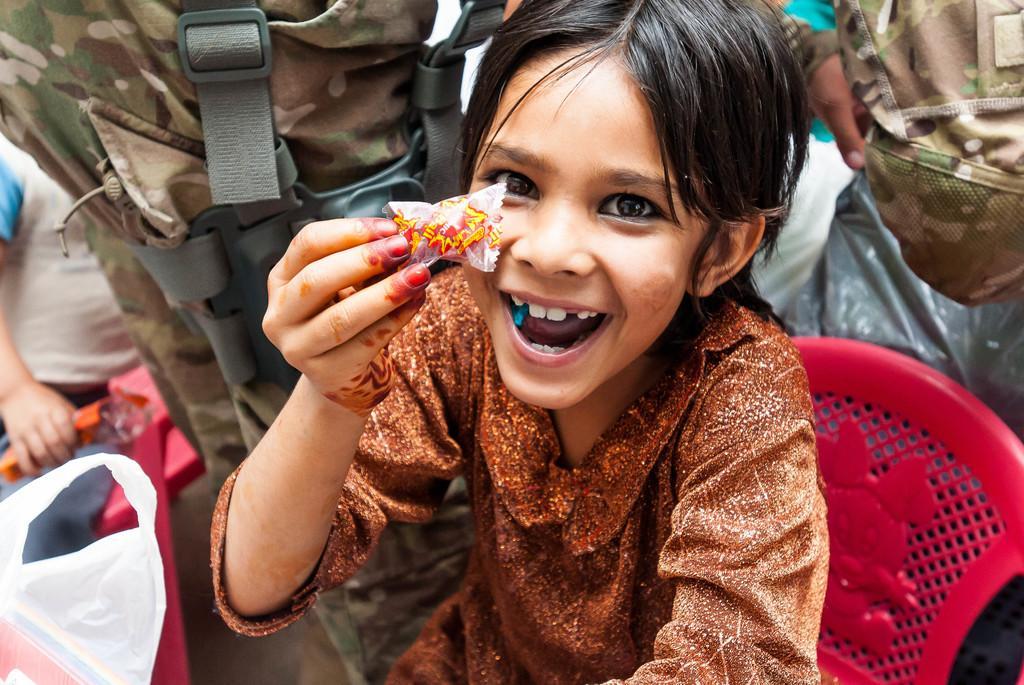In one or two sentences, can you explain what this image depicts? In the foreground of this image, there is a girl holding a chocolate is sitting on a red color chair. Around her, there are people standing. On the left, there is a kid sitting on a chair holding an object. We can also see a cover in the left bottom corner. 